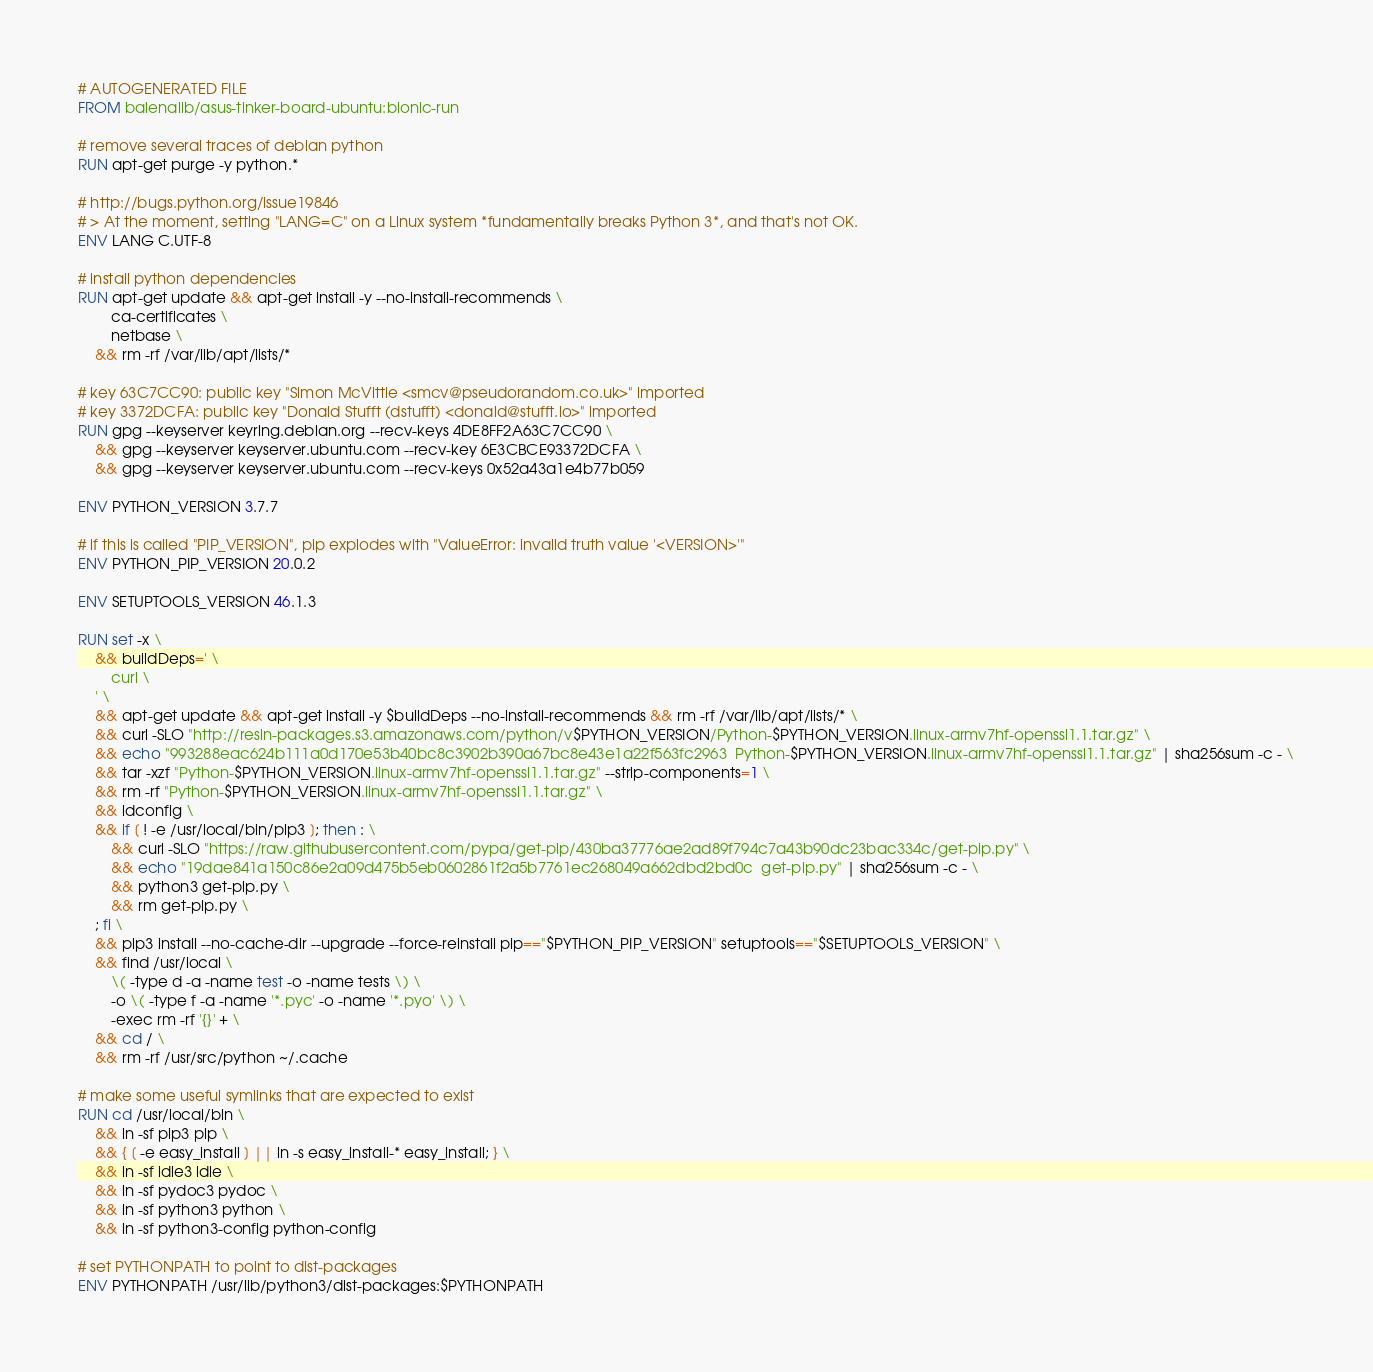Convert code to text. <code><loc_0><loc_0><loc_500><loc_500><_Dockerfile_># AUTOGENERATED FILE
FROM balenalib/asus-tinker-board-ubuntu:bionic-run

# remove several traces of debian python
RUN apt-get purge -y python.*

# http://bugs.python.org/issue19846
# > At the moment, setting "LANG=C" on a Linux system *fundamentally breaks Python 3*, and that's not OK.
ENV LANG C.UTF-8

# install python dependencies
RUN apt-get update && apt-get install -y --no-install-recommends \
		ca-certificates \
		netbase \
	&& rm -rf /var/lib/apt/lists/*

# key 63C7CC90: public key "Simon McVittie <smcv@pseudorandom.co.uk>" imported
# key 3372DCFA: public key "Donald Stufft (dstufft) <donald@stufft.io>" imported
RUN gpg --keyserver keyring.debian.org --recv-keys 4DE8FF2A63C7CC90 \
	&& gpg --keyserver keyserver.ubuntu.com --recv-key 6E3CBCE93372DCFA \
	&& gpg --keyserver keyserver.ubuntu.com --recv-keys 0x52a43a1e4b77b059

ENV PYTHON_VERSION 3.7.7

# if this is called "PIP_VERSION", pip explodes with "ValueError: invalid truth value '<VERSION>'"
ENV PYTHON_PIP_VERSION 20.0.2

ENV SETUPTOOLS_VERSION 46.1.3

RUN set -x \
	&& buildDeps=' \
		curl \
	' \
	&& apt-get update && apt-get install -y $buildDeps --no-install-recommends && rm -rf /var/lib/apt/lists/* \
	&& curl -SLO "http://resin-packages.s3.amazonaws.com/python/v$PYTHON_VERSION/Python-$PYTHON_VERSION.linux-armv7hf-openssl1.1.tar.gz" \
	&& echo "993288eac624b111a0d170e53b40bc8c3902b390a67bc8e43e1a22f563fc2963  Python-$PYTHON_VERSION.linux-armv7hf-openssl1.1.tar.gz" | sha256sum -c - \
	&& tar -xzf "Python-$PYTHON_VERSION.linux-armv7hf-openssl1.1.tar.gz" --strip-components=1 \
	&& rm -rf "Python-$PYTHON_VERSION.linux-armv7hf-openssl1.1.tar.gz" \
	&& ldconfig \
	&& if [ ! -e /usr/local/bin/pip3 ]; then : \
		&& curl -SLO "https://raw.githubusercontent.com/pypa/get-pip/430ba37776ae2ad89f794c7a43b90dc23bac334c/get-pip.py" \
		&& echo "19dae841a150c86e2a09d475b5eb0602861f2a5b7761ec268049a662dbd2bd0c  get-pip.py" | sha256sum -c - \
		&& python3 get-pip.py \
		&& rm get-pip.py \
	; fi \
	&& pip3 install --no-cache-dir --upgrade --force-reinstall pip=="$PYTHON_PIP_VERSION" setuptools=="$SETUPTOOLS_VERSION" \
	&& find /usr/local \
		\( -type d -a -name test -o -name tests \) \
		-o \( -type f -a -name '*.pyc' -o -name '*.pyo' \) \
		-exec rm -rf '{}' + \
	&& cd / \
	&& rm -rf /usr/src/python ~/.cache

# make some useful symlinks that are expected to exist
RUN cd /usr/local/bin \
	&& ln -sf pip3 pip \
	&& { [ -e easy_install ] || ln -s easy_install-* easy_install; } \
	&& ln -sf idle3 idle \
	&& ln -sf pydoc3 pydoc \
	&& ln -sf python3 python \
	&& ln -sf python3-config python-config

# set PYTHONPATH to point to dist-packages
ENV PYTHONPATH /usr/lib/python3/dist-packages:$PYTHONPATH
</code> 